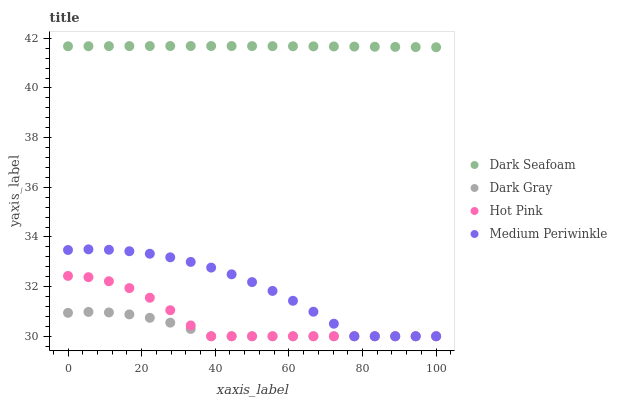Does Dark Gray have the minimum area under the curve?
Answer yes or no. Yes. Does Dark Seafoam have the maximum area under the curve?
Answer yes or no. Yes. Does Hot Pink have the minimum area under the curve?
Answer yes or no. No. Does Hot Pink have the maximum area under the curve?
Answer yes or no. No. Is Dark Seafoam the smoothest?
Answer yes or no. Yes. Is Hot Pink the roughest?
Answer yes or no. Yes. Is Hot Pink the smoothest?
Answer yes or no. No. Is Dark Seafoam the roughest?
Answer yes or no. No. Does Dark Gray have the lowest value?
Answer yes or no. Yes. Does Dark Seafoam have the lowest value?
Answer yes or no. No. Does Dark Seafoam have the highest value?
Answer yes or no. Yes. Does Hot Pink have the highest value?
Answer yes or no. No. Is Dark Gray less than Dark Seafoam?
Answer yes or no. Yes. Is Dark Seafoam greater than Medium Periwinkle?
Answer yes or no. Yes. Does Dark Gray intersect Medium Periwinkle?
Answer yes or no. Yes. Is Dark Gray less than Medium Periwinkle?
Answer yes or no. No. Is Dark Gray greater than Medium Periwinkle?
Answer yes or no. No. Does Dark Gray intersect Dark Seafoam?
Answer yes or no. No. 